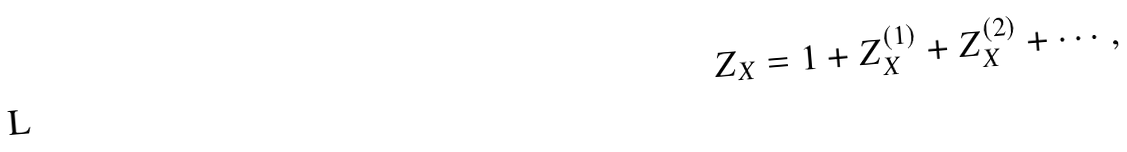Convert formula to latex. <formula><loc_0><loc_0><loc_500><loc_500>Z _ { X } = 1 + Z _ { X } ^ { ( 1 ) } + Z _ { X } ^ { ( 2 ) } + \cdots ,</formula> 